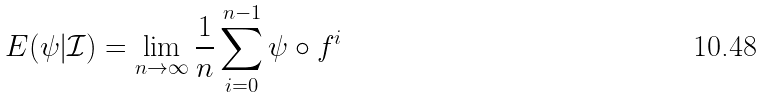Convert formula to latex. <formula><loc_0><loc_0><loc_500><loc_500>E ( \psi | \mathcal { I } ) = \lim _ { n \to \infty } \frac { 1 } { n } \sum _ { i = 0 } ^ { n - 1 } \psi \circ f ^ { i }</formula> 